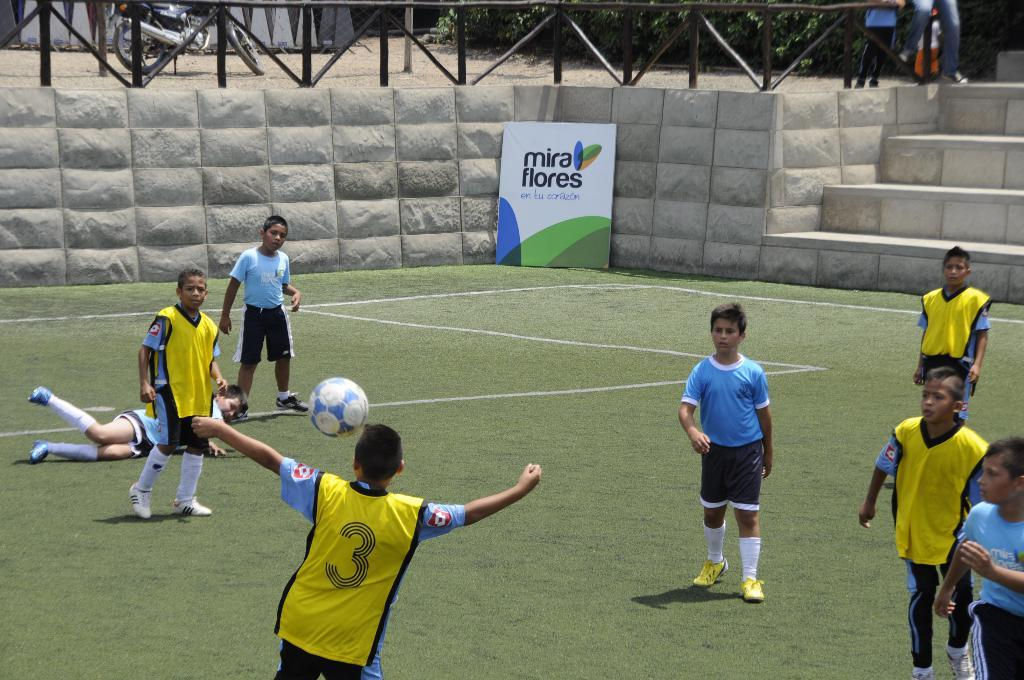Who is present in the image? There are boys in the image. What activity are the boys engaged in? The boys are playing football. Where is the football game taking place? The football game is taking place on the ground. What else can be seen in the image? There is a motorcycle visible in the top left corner of the image. Can you see any rabbits playing with the boys during the football game? There are no rabbits present in the image; it only features boys playing football and a motorcycle in the top left corner. 